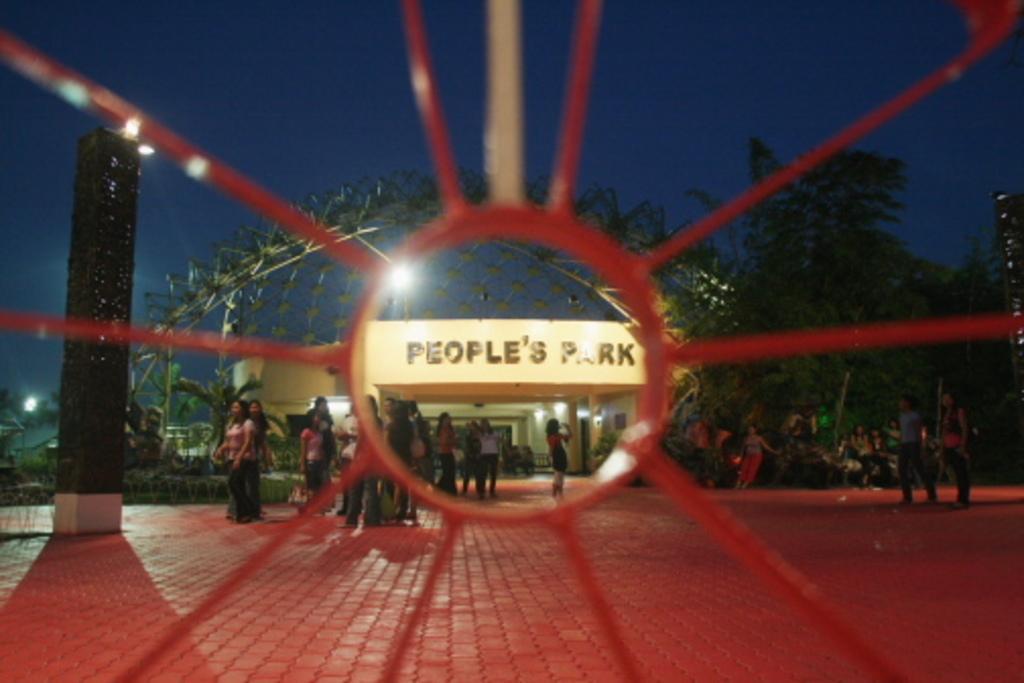Could you give a brief overview of what you see in this image? In this picture I can see few trees and few people are standing and I can see a building with some text on the wall and I can see few lights and a metal fence and tall buildings on both sides. 